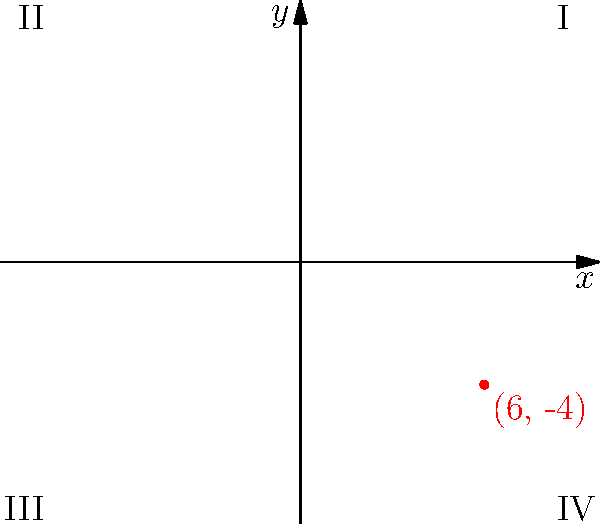In a recent military operation, a human rights violation was reported at coordinates (6, -4). In which quadrant of the coordinate system did this incident occur? To determine the quadrant where the incident occurred, we need to analyze the given coordinates (6, -4). Here's a step-by-step approach:

1. Recall the quadrant definitions in a coordinate system:
   - Quadrant I: Both x and y are positive (+, +)
   - Quadrant II: x is negative, y is positive (-, +)
   - Quadrant III: Both x and y are negative (-, -)
   - Quadrant IV: x is positive, y is negative (+, -)

2. Examine the given coordinates (6, -4):
   - The x-coordinate is 6, which is positive
   - The y-coordinate is -4, which is negative

3. Compare these values to the quadrant definitions:
   - We have a positive x and a negative y
   - This combination corresponds to Quadrant IV

Therefore, the reported incident occurred in Quadrant IV of the coordinate system.
Answer: Quadrant IV 